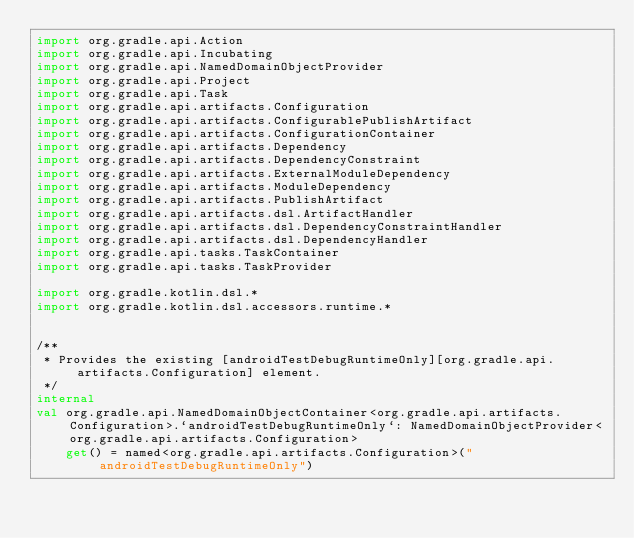<code> <loc_0><loc_0><loc_500><loc_500><_Kotlin_>import org.gradle.api.Action
import org.gradle.api.Incubating
import org.gradle.api.NamedDomainObjectProvider
import org.gradle.api.Project
import org.gradle.api.Task
import org.gradle.api.artifacts.Configuration
import org.gradle.api.artifacts.ConfigurablePublishArtifact
import org.gradle.api.artifacts.ConfigurationContainer
import org.gradle.api.artifacts.Dependency
import org.gradle.api.artifacts.DependencyConstraint
import org.gradle.api.artifacts.ExternalModuleDependency
import org.gradle.api.artifacts.ModuleDependency
import org.gradle.api.artifacts.PublishArtifact
import org.gradle.api.artifacts.dsl.ArtifactHandler
import org.gradle.api.artifacts.dsl.DependencyConstraintHandler
import org.gradle.api.artifacts.dsl.DependencyHandler
import org.gradle.api.tasks.TaskContainer
import org.gradle.api.tasks.TaskProvider

import org.gradle.kotlin.dsl.*
import org.gradle.kotlin.dsl.accessors.runtime.*


/**
 * Provides the existing [androidTestDebugRuntimeOnly][org.gradle.api.artifacts.Configuration] element.
 */
internal
val org.gradle.api.NamedDomainObjectContainer<org.gradle.api.artifacts.Configuration>.`androidTestDebugRuntimeOnly`: NamedDomainObjectProvider<org.gradle.api.artifacts.Configuration>
    get() = named<org.gradle.api.artifacts.Configuration>("androidTestDebugRuntimeOnly")


</code> 